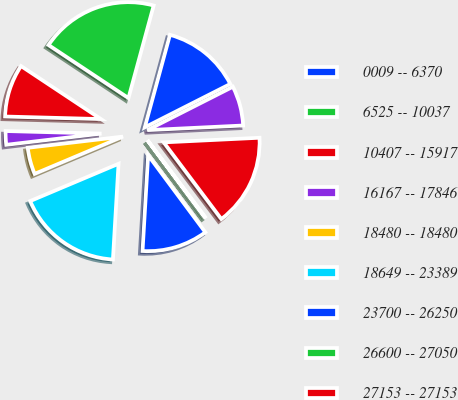Convert chart. <chart><loc_0><loc_0><loc_500><loc_500><pie_chart><fcel>0009 -- 6370<fcel>6525 -- 10037<fcel>10407 -- 15917<fcel>16167 -- 17846<fcel>18480 -- 18480<fcel>18649 -- 23389<fcel>23700 -- 26250<fcel>26600 -- 27050<fcel>27153 -- 27153<fcel>27170 -- 35080<nl><fcel>13.3%<fcel>19.91%<fcel>8.9%<fcel>2.29%<fcel>4.49%<fcel>17.71%<fcel>11.1%<fcel>0.09%<fcel>15.51%<fcel>6.7%<nl></chart> 